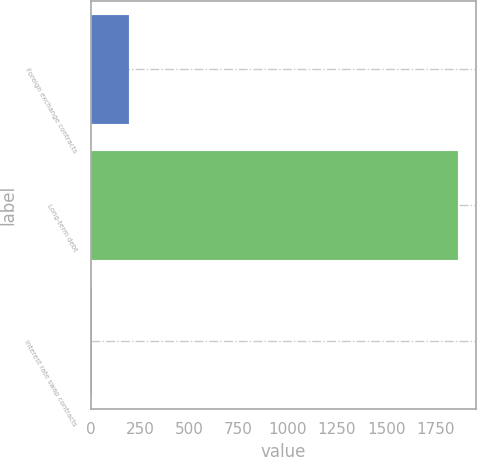<chart> <loc_0><loc_0><loc_500><loc_500><bar_chart><fcel>Foreign exchange contracts<fcel>Long-term debt<fcel>Interest rate swap contracts<nl><fcel>192.5<fcel>1862<fcel>7<nl></chart> 